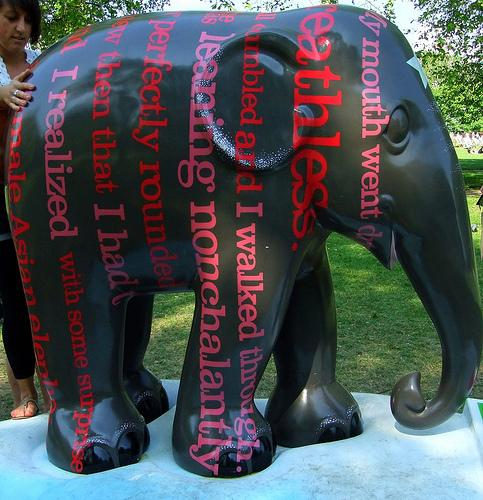What is the primary object in the image and its color? The primary object is a large black statue of an elephant. How would you rate the quality of the photograph based on the provided information? The photo looks very great, according to the image information. Identify the location of any writing on the elephant statue and its color. There is red writing on various parts of the elephant statue. What type of footwear can be seen in the image, and where is it located? Flip flops on a woman's foot, located at the bottom left corner of the image. Mention any unique markings on the elephant statue and their color. There are red writings and a blue star on the elephant statue. Name one body part of the elephant statue and its relative position in the image. The trunk of the statue is towards the top right of the image. What is a person in the image doing, and what is their attire? A woman is touching the statue, wearing black pants, and a pair of sandals. How would you describe the area on which the elephant statue is standing? The statue is standing on a light blue platform, which is on a blue mat. Are there any plants or natural elements in the image? If so, describe them. Yes, there are dark green leaves and a large piece of green grass in the image. Mention one specific feature of the elephant statue and its color. The elephant statue has a blue star on its forehead. The elephant statue is wearing a fancy golden hat. None of the image data describes a golden hat on the elephant statue. The use of a declarative sentence instructs the viewer to look for an object that does not exist in the image, leading to confusion. What unique feature is visible on the elephant's forehead? Part of a blue star What is the general opinion about the photo according to the captions given? This photo looks very great. Is there anything out of the ordinary or unusual in this image? No, it appears to be a normal picture of a statue and a woman. What is the main subject in the foreground of the photograph? A large elephant statue in a park. Rate the quality of this image on a scale of 1 to 5. 4, as it seems clear with distinguishable objects. What are the dimensions of the trunk of the elephant statue? Width:87 Height:87 Describe the main object in the image. A large black statue of an elephant. What is written on this elephant? There is the word "some" on this elephant. What is the name of the person who took this photo? Jackson Mingus How many red writings are there on the elephant? 10 Identify the position and size of the "blue mat the statue stands on". X:0 Y:379 Width:481 Height:481 Can you explain what the blue and white striped scarf wrapped around the statue's trunk signifies? The image data does not reference a blue and white striped scarf on the elephant's trunk. By asking a question related to the meaning of a non-existent object, the viewer's attention is misdirected, and they may try to find meaning in something that isn't there. Notice the purple umbrella leaning against the statue. In the given image data, there is no mention of a purple umbrella. A declarative sentence instructs the viewer to focus on a non-existent object, creating confusion. Is the woman touching the statue wearing sandals, flip flops, or shoes? Flip flops How would you describe the sentiment of the image? Positive, as it depicts a beautiful statue. What color is the writing on the elephant statue? Red Is the pants of the person wearing sandals, black or blue? Black Is the statue of the elephant sitting or standing? Standing Identify the presence of any green vegetation within the image. There are dark green leaves at X:444 Y:40 Width:17 Height:17. Identify the position and dimensions of the eye on the elephant statue. X:374 Y:98 Width:41 Height:41 Spot the smiling blue turtle figure sitting next to the woman's foot. There is no mention of a smiling blue turtle figure in the given image data. A declarative sentence pointing out a non-existent object makes the viewer think they have missed something in the image, leading to confusion. In what way is the woman interacting with the statue? She's touching the statue with her hand. Point out the location of the light blue platform in the image. X:355 Y:265 Width:14 Height:14 Where might the orange butterfly be on the green leaves near the statue? The image data mentions dark green leaves, but there is no mention of an orange butterfly. An interrogative sentence asking about the butterfly's location makes the viewer wonder if they missed seeing something in the image. Can you find the small yellow bird sitting on the elephant statue's ear? There is no information about a small yellow bird in the image data provided. The use of an interrogative sentence makes the viewer question the existence of an object in the image, even though it doesn't exist. 